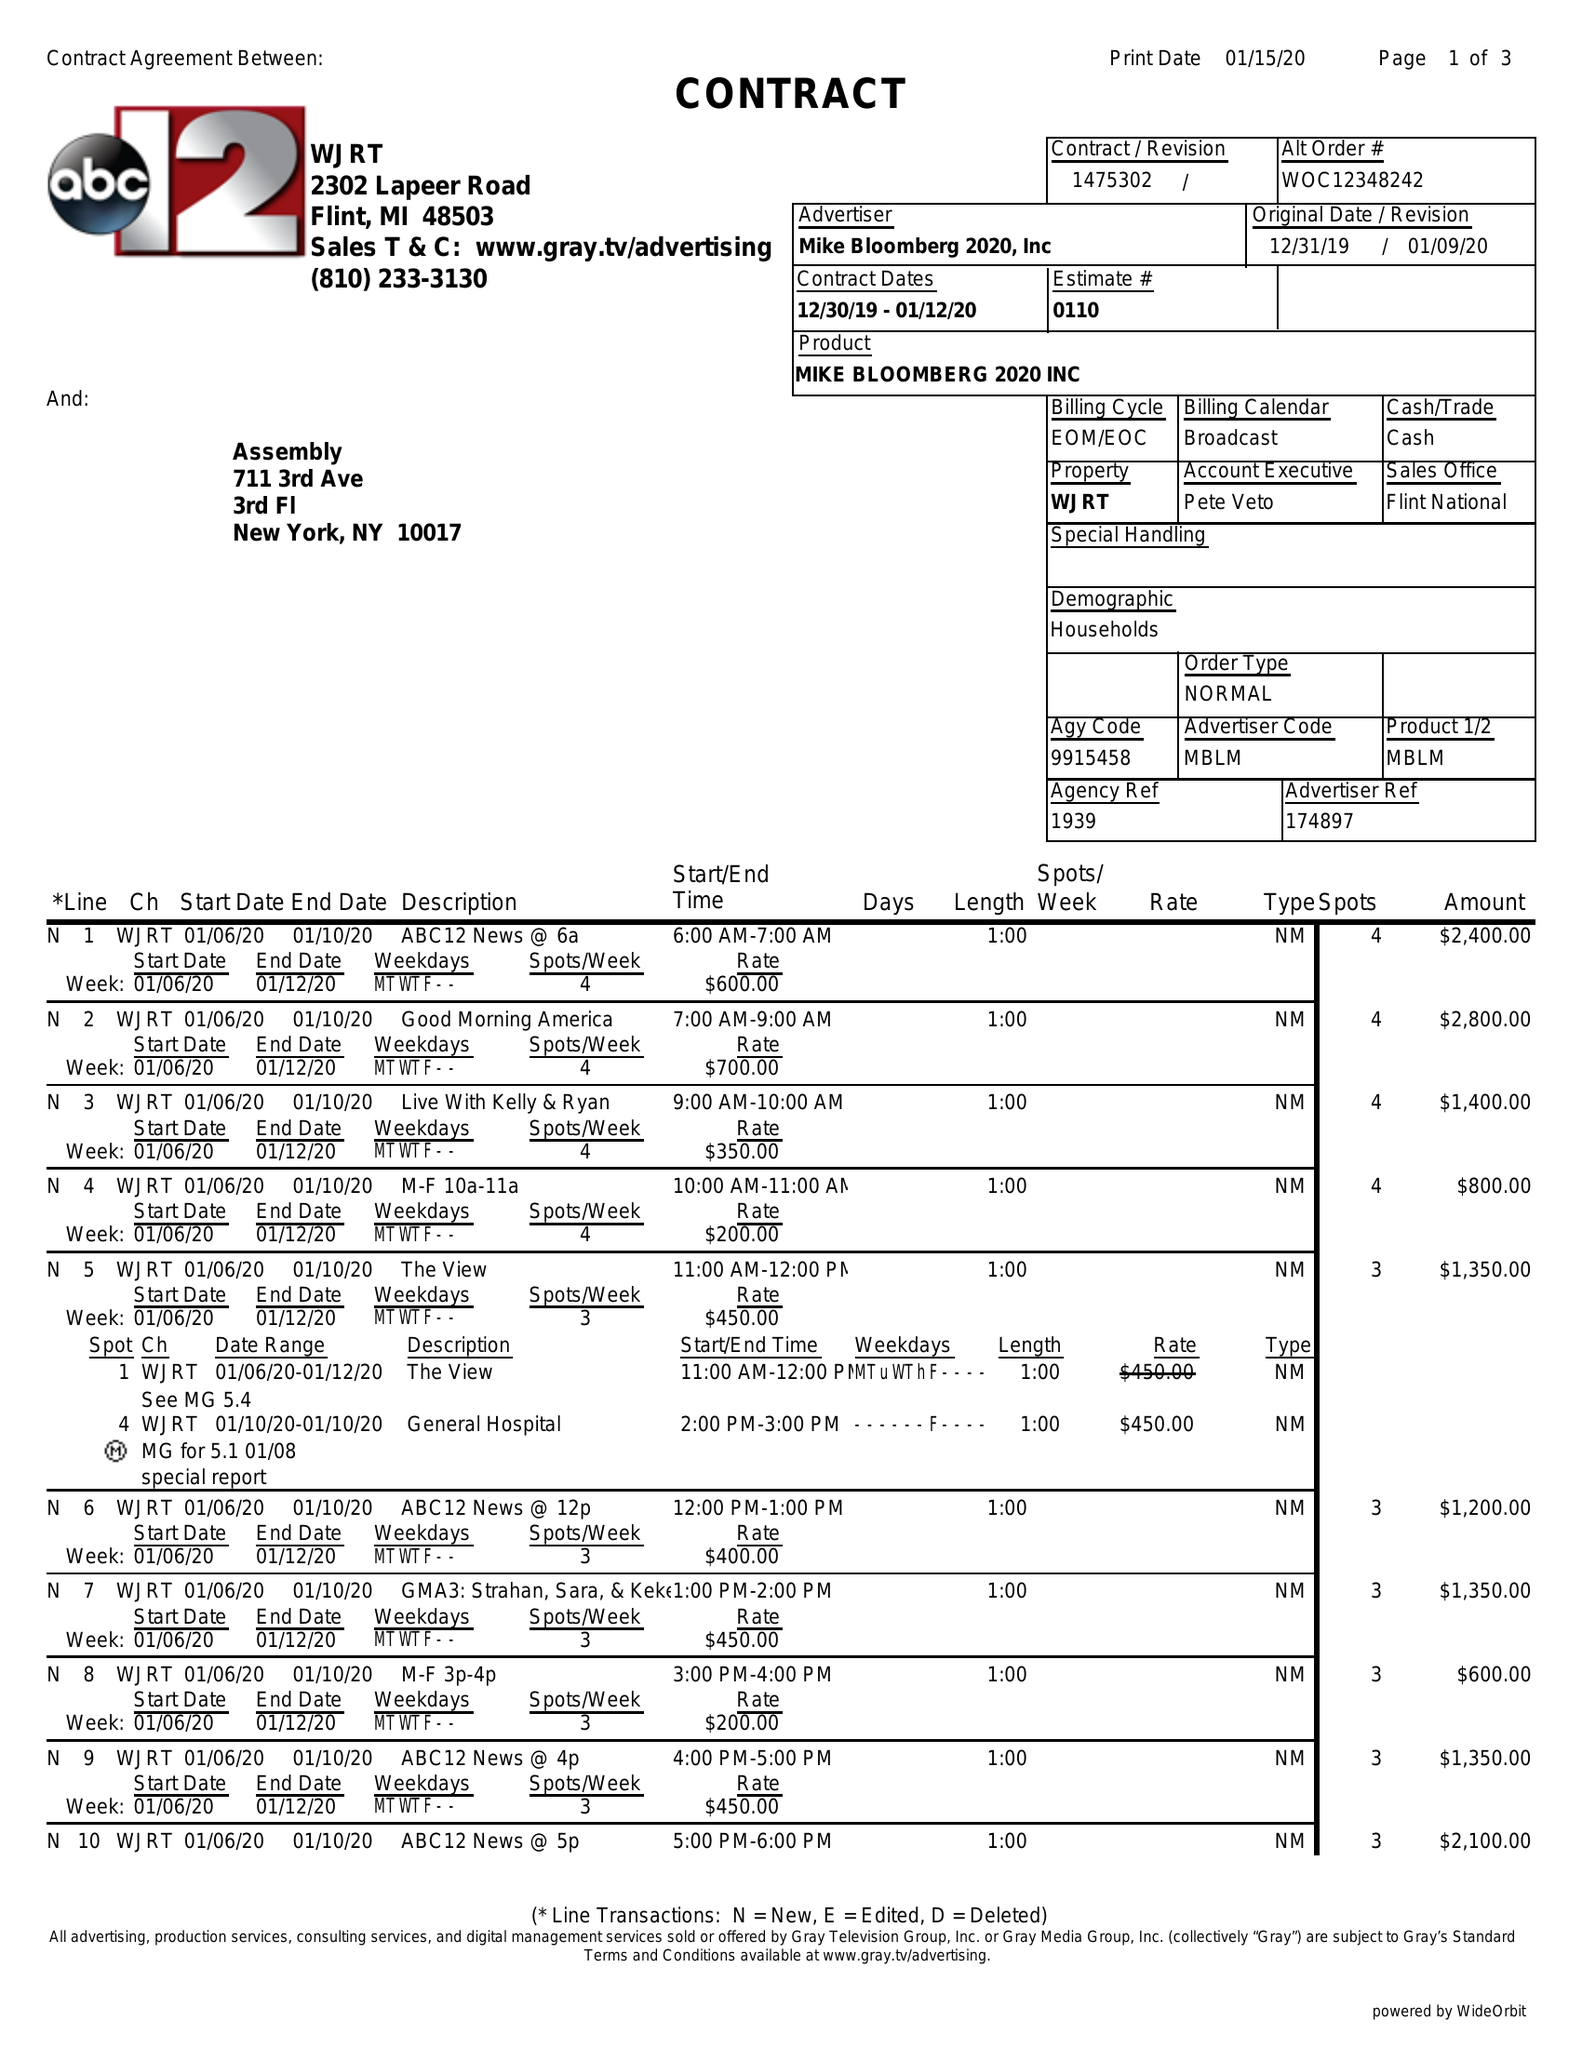What is the value for the advertiser?
Answer the question using a single word or phrase. MIKE BLOOMBERG 2020, INC 